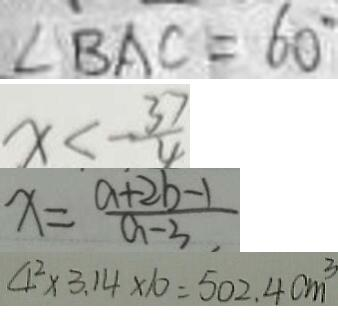<formula> <loc_0><loc_0><loc_500><loc_500>\angle B A C = 6 0 ^ { \circ } 
 x < - \frac { 3 7 } { 4 } 
 x = \frac { a + 2 b - 1 } { a - 3 } 
 4 ^ { 2 } \times 3 . 1 4 \times 1 0 = 5 0 2 . 4 c m ^ { 3 }</formula> 